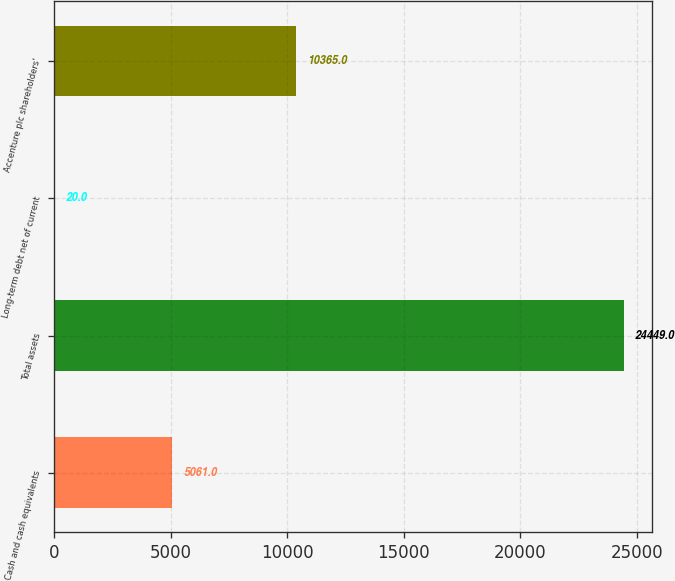Convert chart. <chart><loc_0><loc_0><loc_500><loc_500><bar_chart><fcel>Cash and cash equivalents<fcel>Total assets<fcel>Long-term debt net of current<fcel>Accenture plc shareholders'<nl><fcel>5061<fcel>24449<fcel>20<fcel>10365<nl></chart> 